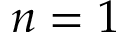Convert formula to latex. <formula><loc_0><loc_0><loc_500><loc_500>n = 1</formula> 